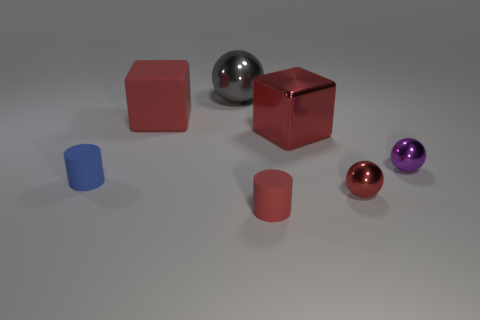Add 1 large red matte blocks. How many objects exist? 8 Subtract all cylinders. How many objects are left? 5 Add 7 small red shiny blocks. How many small red shiny blocks exist? 7 Subtract 0 blue balls. How many objects are left? 7 Subtract all tiny red rubber blocks. Subtract all small red matte cylinders. How many objects are left? 6 Add 1 large spheres. How many large spheres are left? 2 